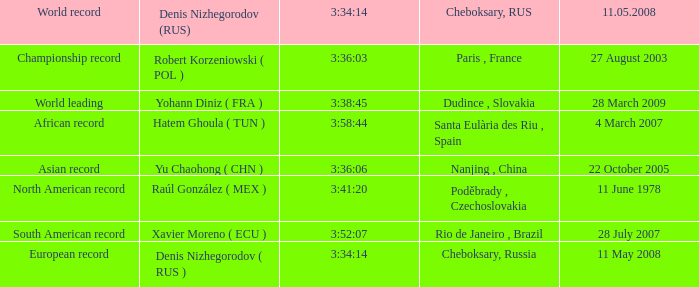When 3:41:20 is  3:34:14 what is cheboksary , russia? Poděbrady , Czechoslovakia. 